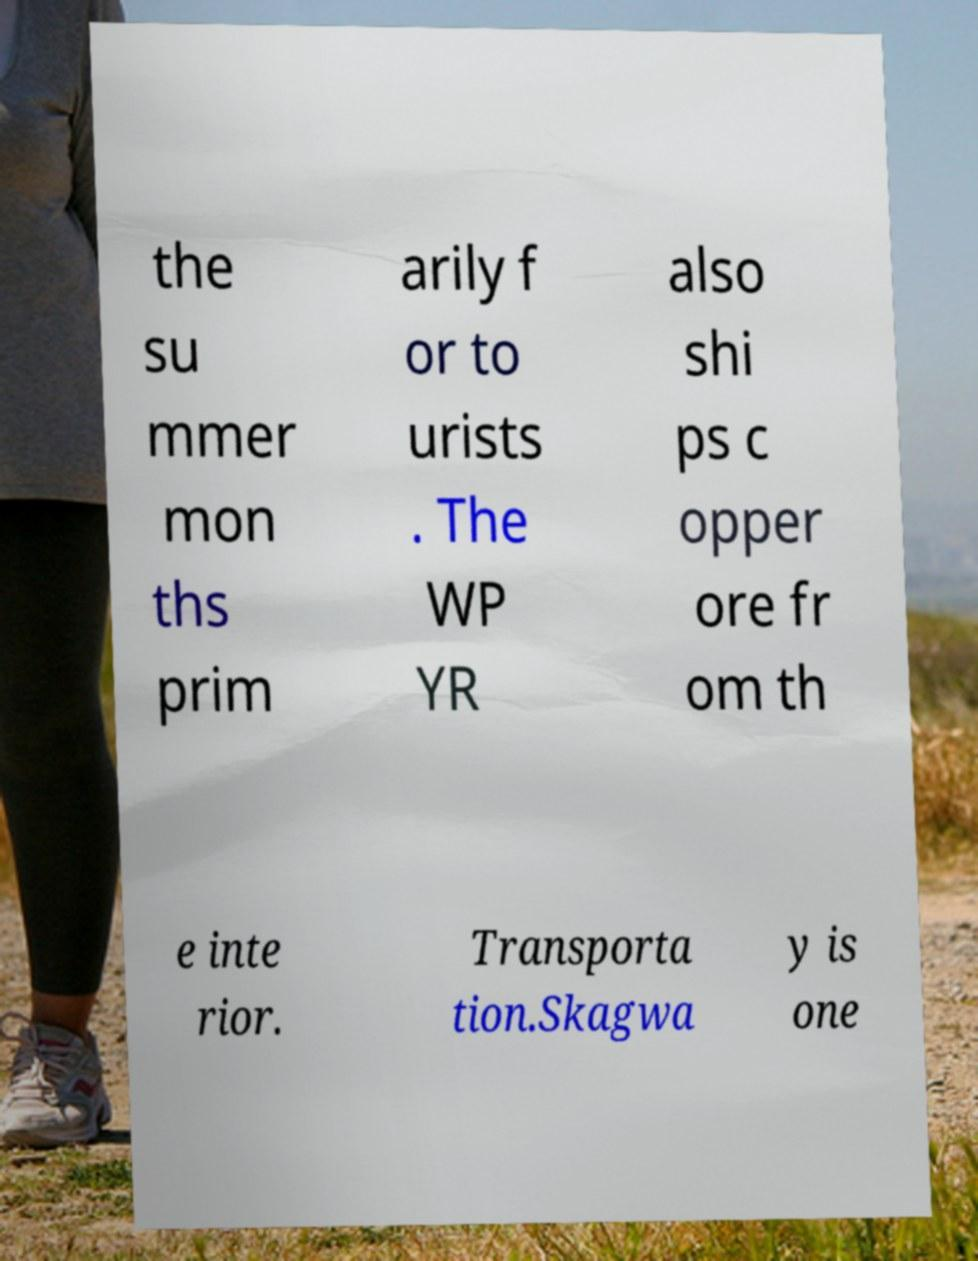I need the written content from this picture converted into text. Can you do that? the su mmer mon ths prim arily f or to urists . The WP YR also shi ps c opper ore fr om th e inte rior. Transporta tion.Skagwa y is one 